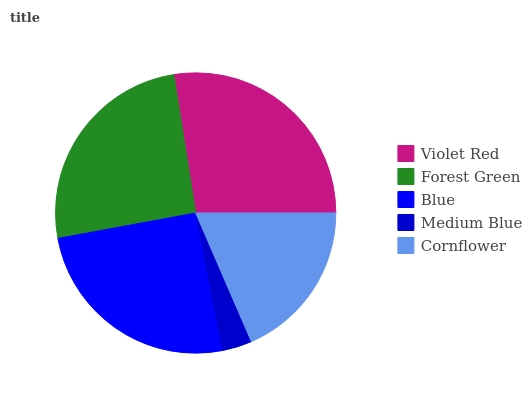Is Medium Blue the minimum?
Answer yes or no. Yes. Is Violet Red the maximum?
Answer yes or no. Yes. Is Forest Green the minimum?
Answer yes or no. No. Is Forest Green the maximum?
Answer yes or no. No. Is Violet Red greater than Forest Green?
Answer yes or no. Yes. Is Forest Green less than Violet Red?
Answer yes or no. Yes. Is Forest Green greater than Violet Red?
Answer yes or no. No. Is Violet Red less than Forest Green?
Answer yes or no. No. Is Blue the high median?
Answer yes or no. Yes. Is Blue the low median?
Answer yes or no. Yes. Is Medium Blue the high median?
Answer yes or no. No. Is Medium Blue the low median?
Answer yes or no. No. 